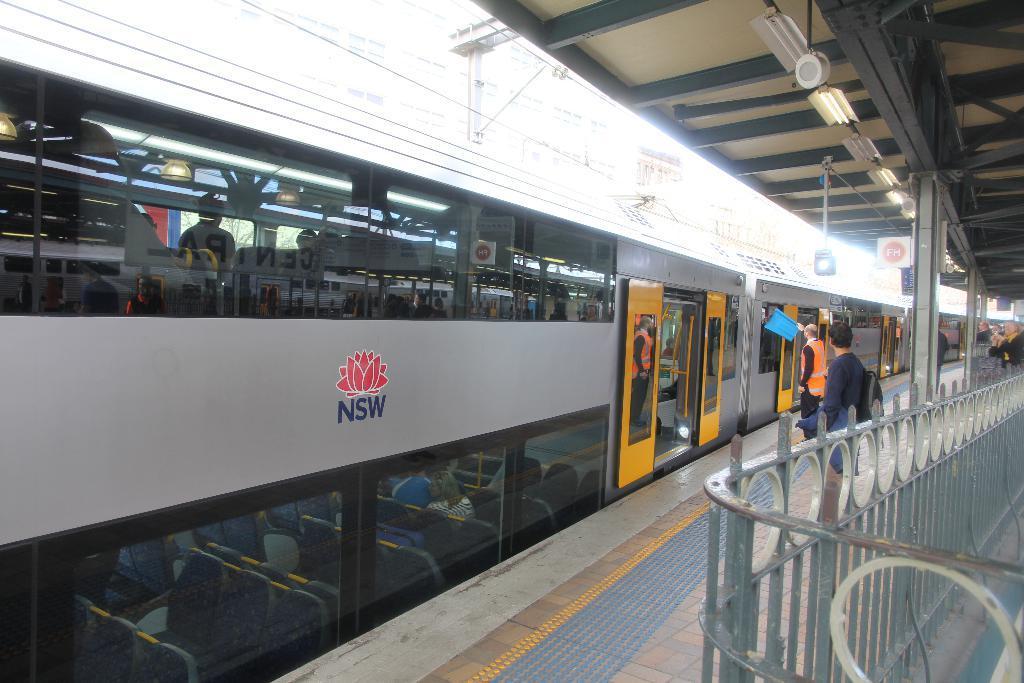Can you describe this image briefly? In this picture we can see a train with a group of people sitting inside it and some people standing on a platform, fence, wires. 